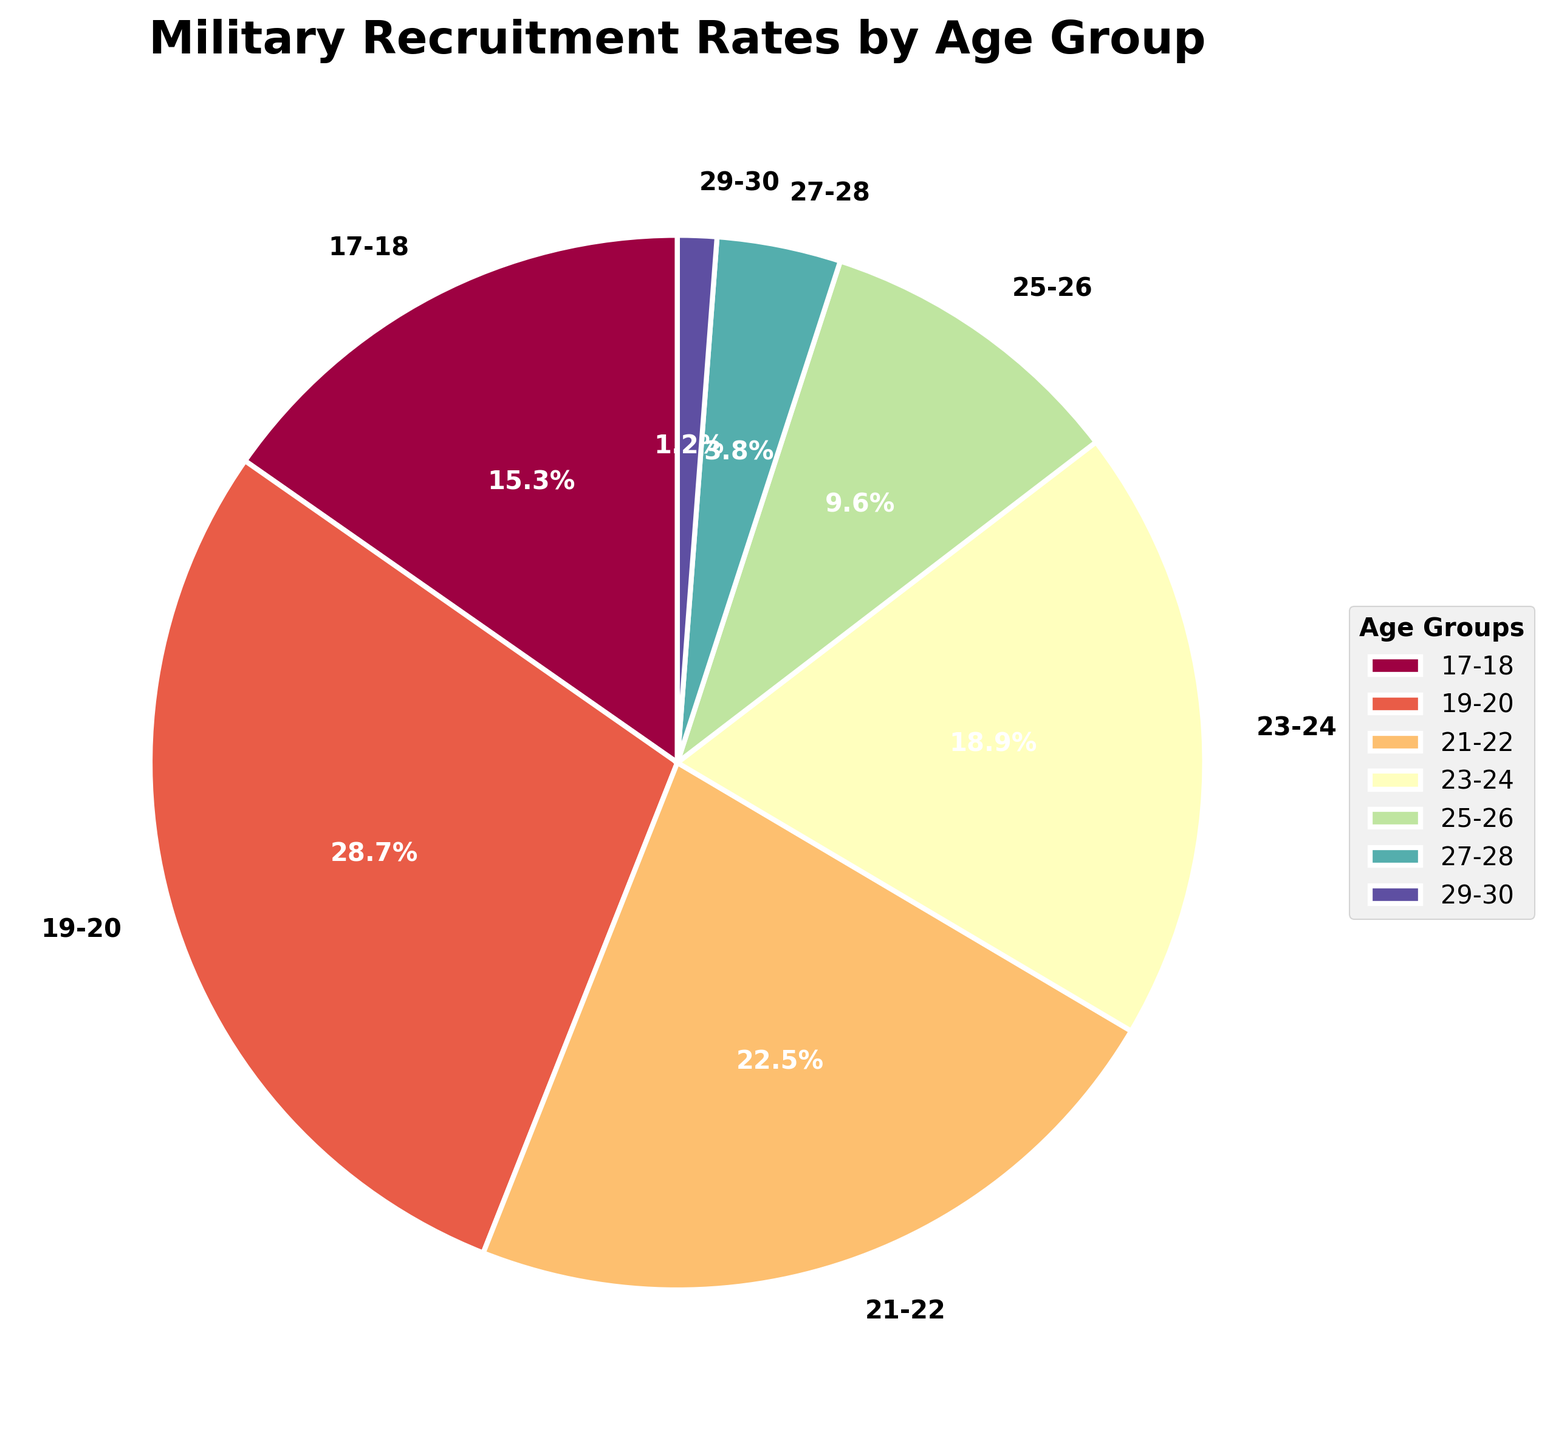What age group has the highest recruitment rate? The figure labels show the recruitment rate for each age group, and the largest slice corresponds to the 19-20 age group.
Answer: 19-20 What is the combined recruitment rate for the age groups 23-24 and 25-26? Add the recruitment rates for 23-24 and 25-26: 18.9% + 9.6%.
Answer: 28.5% Which age group contributes the least to the recruitment rate? The smallest slice in the pie chart represents the age group 29-30.
Answer: 29-30 How does the recruitment rate for the age group 21-22 compare to that of 17-18? The recruitment rate for 21-22 is 22.5%, which is higher than the 17-18 age group at 15.3%.
Answer: 21-22 is higher What percentage of the total recruitment rate do the age groups 27-28 and 29-30 together account for? Add the recruitment rates for 27-28 and 29-30: 3.8% + 1.2%.
Answer: 5.0% Which age group is represented by a larger slice: 23-24 or 21-22? The recruitment rate for 21-22 is 22.5%, whereas it is 18.9% for the 23-24 age group.
Answer: 21-22 What is the sum of the recruitment rates for the ages above 22? Add the recruitment rates for 23-24, 25-26, 27-28, and 29-30: 18.9% + 9.6% + 3.8% + 1.2%.
Answer: 33.5% Which age group has a recruitment rate just under 10%? The pie chart shows that the recruitment rate for the 25-26 age group is 9.6%.
Answer: 25-26 What is the difference in recruitment rates between the age groups 19-20 and 25-26? Subtract the recruitment rate for 25-26 (9.6%) from that for 19-20 (28.7%): 28.7% - 9.6%.
Answer: 19.1% How many age groups have a recruitment rate greater than 20%? The pie chart shows that the age groups 19-20 (28.7%) and 21-22 (22.5%) both have rates greater than 20%.
Answer: 2 